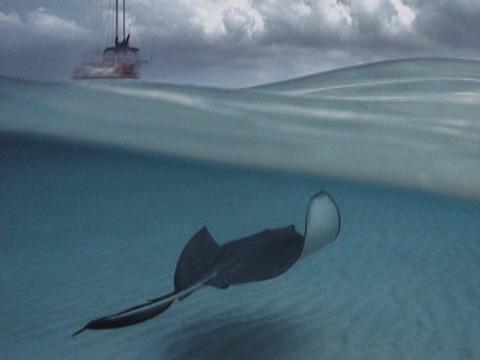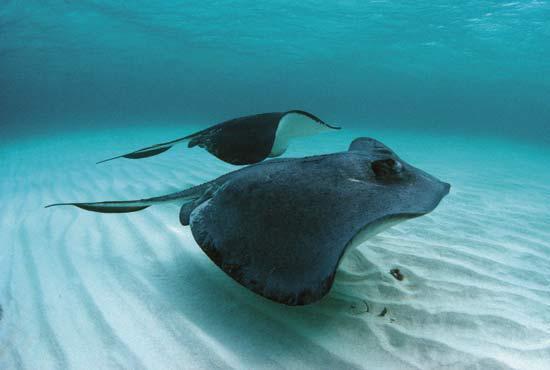The first image is the image on the left, the second image is the image on the right. Given the left and right images, does the statement "One image in the pair has a human." hold true? Answer yes or no. No. The first image is the image on the left, the second image is the image on the right. For the images shown, is this caption "One image shows at least one person in the water with a stingray." true? Answer yes or no. No. 